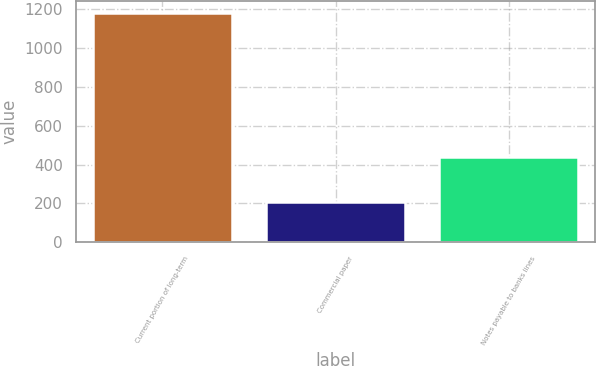Convert chart. <chart><loc_0><loc_0><loc_500><loc_500><bar_chart><fcel>Current portion of long-term<fcel>Commercial paper<fcel>Notes payable to banks lines<nl><fcel>1182<fcel>208<fcel>441<nl></chart> 